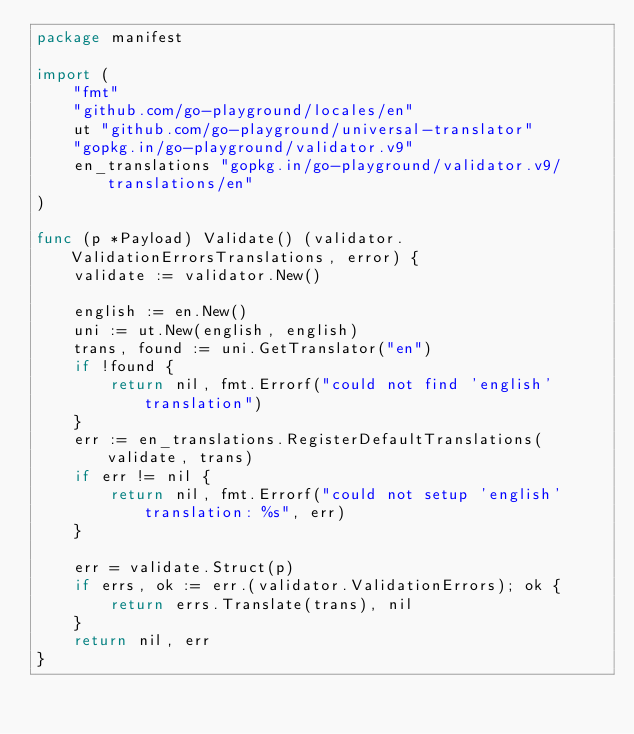Convert code to text. <code><loc_0><loc_0><loc_500><loc_500><_Go_>package manifest

import (
	"fmt"
	"github.com/go-playground/locales/en"
	ut "github.com/go-playground/universal-translator"
	"gopkg.in/go-playground/validator.v9"
	en_translations "gopkg.in/go-playground/validator.v9/translations/en"
)

func (p *Payload) Validate() (validator.ValidationErrorsTranslations, error) {
	validate := validator.New()

	english := en.New()
	uni := ut.New(english, english)
	trans, found := uni.GetTranslator("en")
	if !found {
		return nil, fmt.Errorf("could not find 'english' translation")
	}
	err := en_translations.RegisterDefaultTranslations(validate, trans)
	if err != nil {
		return nil, fmt.Errorf("could not setup 'english' translation: %s", err)
	}

	err = validate.Struct(p)
	if errs, ok := err.(validator.ValidationErrors); ok {
		return errs.Translate(trans), nil
	}
	return nil, err
}
</code> 